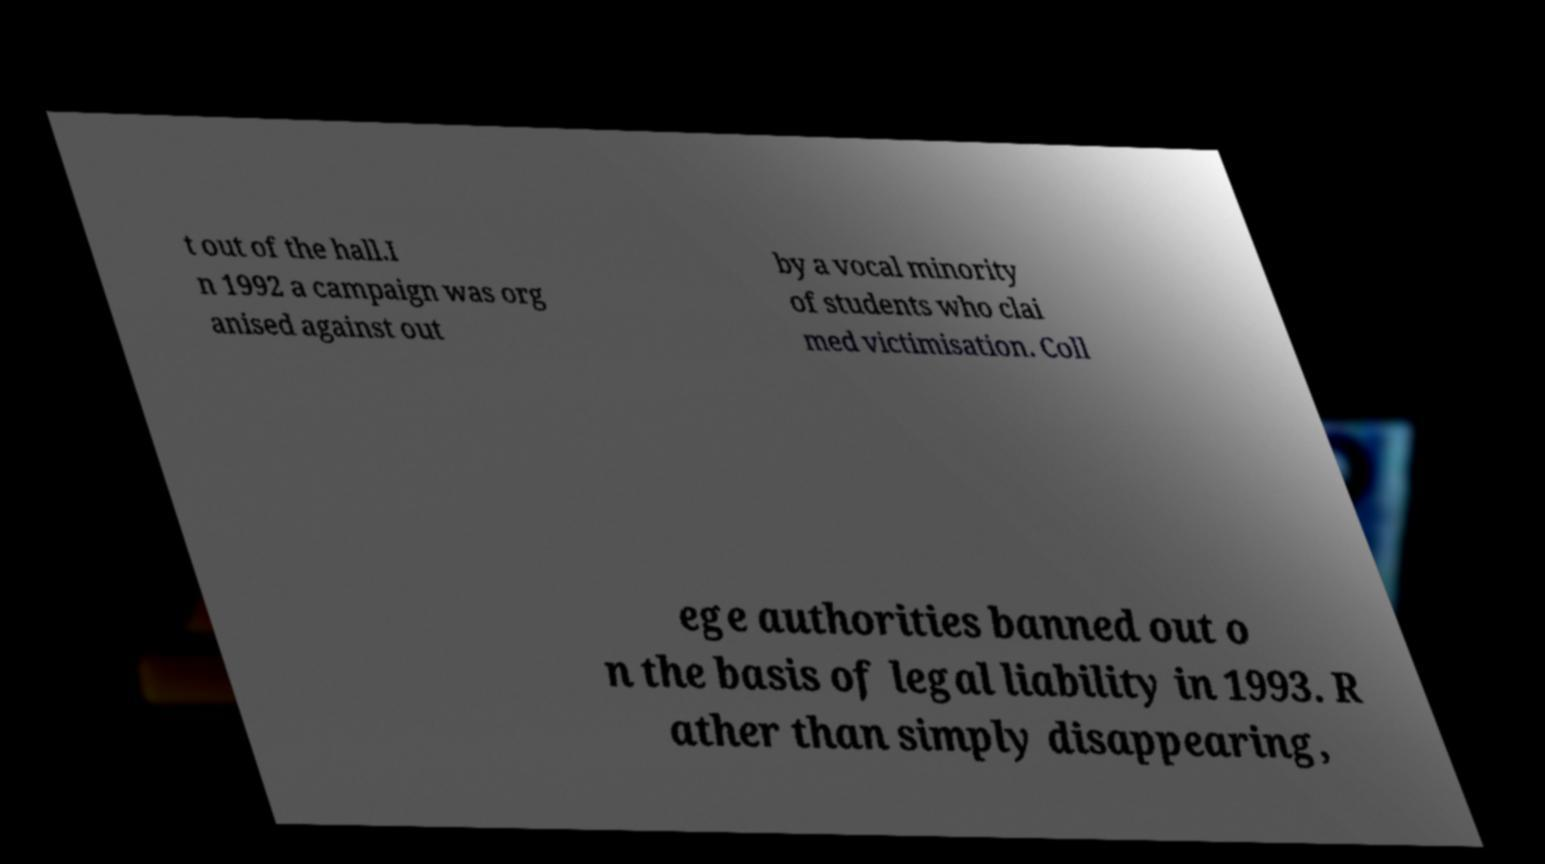Can you read and provide the text displayed in the image?This photo seems to have some interesting text. Can you extract and type it out for me? t out of the hall.I n 1992 a campaign was org anised against out by a vocal minority of students who clai med victimisation. Coll ege authorities banned out o n the basis of legal liability in 1993. R ather than simply disappearing, 